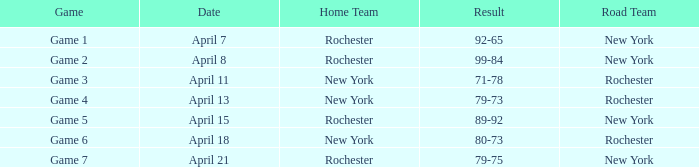Which Date has a Game of game 3? April 11. 